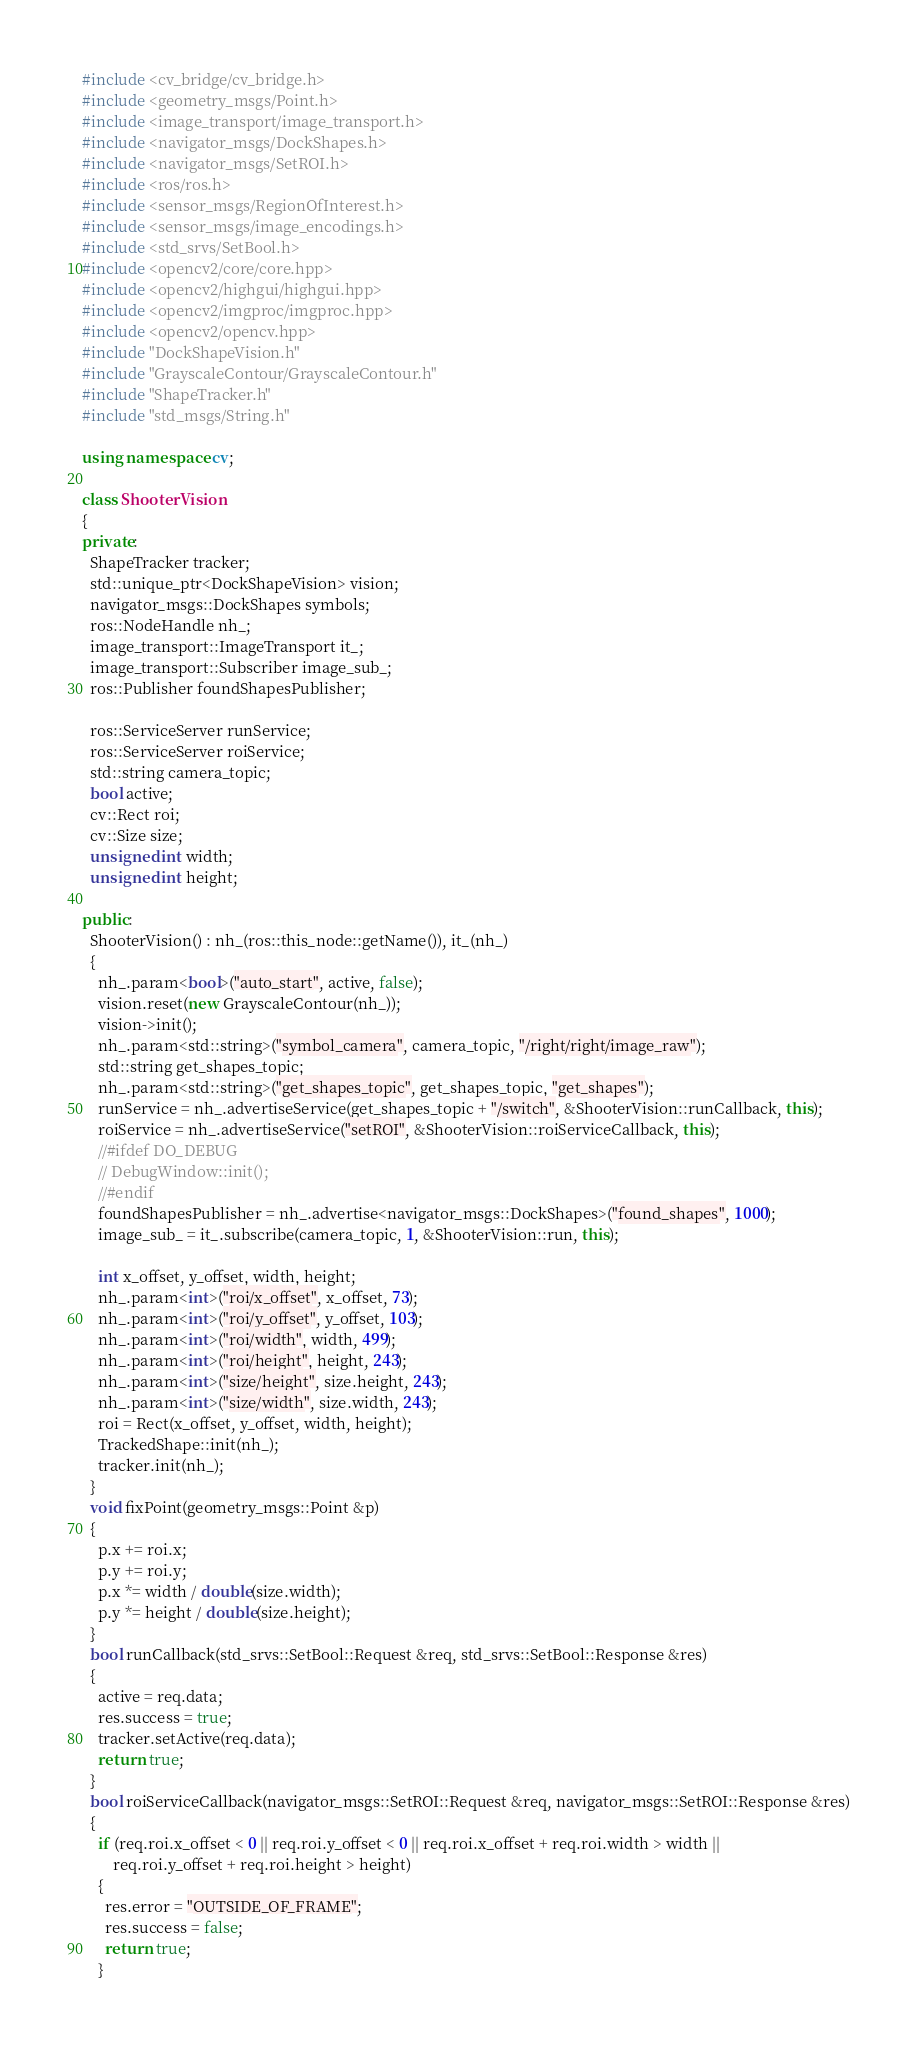Convert code to text. <code><loc_0><loc_0><loc_500><loc_500><_C++_>#include <cv_bridge/cv_bridge.h>
#include <geometry_msgs/Point.h>
#include <image_transport/image_transport.h>
#include <navigator_msgs/DockShapes.h>
#include <navigator_msgs/SetROI.h>
#include <ros/ros.h>
#include <sensor_msgs/RegionOfInterest.h>
#include <sensor_msgs/image_encodings.h>
#include <std_srvs/SetBool.h>
#include <opencv2/core/core.hpp>
#include <opencv2/highgui/highgui.hpp>
#include <opencv2/imgproc/imgproc.hpp>
#include <opencv2/opencv.hpp>
#include "DockShapeVision.h"
#include "GrayscaleContour/GrayscaleContour.h"
#include "ShapeTracker.h"
#include "std_msgs/String.h"

using namespace cv;

class ShooterVision
{
private:
  ShapeTracker tracker;
  std::unique_ptr<DockShapeVision> vision;
  navigator_msgs::DockShapes symbols;
  ros::NodeHandle nh_;
  image_transport::ImageTransport it_;
  image_transport::Subscriber image_sub_;
  ros::Publisher foundShapesPublisher;

  ros::ServiceServer runService;
  ros::ServiceServer roiService;
  std::string camera_topic;
  bool active;
  cv::Rect roi;
  cv::Size size;
  unsigned int width;
  unsigned int height;

public:
  ShooterVision() : nh_(ros::this_node::getName()), it_(nh_)
  {
    nh_.param<bool>("auto_start", active, false);
    vision.reset(new GrayscaleContour(nh_));
    vision->init();
    nh_.param<std::string>("symbol_camera", camera_topic, "/right/right/image_raw");
    std::string get_shapes_topic;
    nh_.param<std::string>("get_shapes_topic", get_shapes_topic, "get_shapes");
    runService = nh_.advertiseService(get_shapes_topic + "/switch", &ShooterVision::runCallback, this);
    roiService = nh_.advertiseService("setROI", &ShooterVision::roiServiceCallback, this);
    //#ifdef DO_DEBUG
    // DebugWindow::init();
    //#endif
    foundShapesPublisher = nh_.advertise<navigator_msgs::DockShapes>("found_shapes", 1000);
    image_sub_ = it_.subscribe(camera_topic, 1, &ShooterVision::run, this);

    int x_offset, y_offset, width, height;
    nh_.param<int>("roi/x_offset", x_offset, 73);
    nh_.param<int>("roi/y_offset", y_offset, 103);
    nh_.param<int>("roi/width", width, 499);
    nh_.param<int>("roi/height", height, 243);
    nh_.param<int>("size/height", size.height, 243);
    nh_.param<int>("size/width", size.width, 243);
    roi = Rect(x_offset, y_offset, width, height);
    TrackedShape::init(nh_);
    tracker.init(nh_);
  }
  void fixPoint(geometry_msgs::Point &p)
  {
    p.x += roi.x;
    p.y += roi.y;
    p.x *= width / double(size.width);
    p.y *= height / double(size.height);
  }
  bool runCallback(std_srvs::SetBool::Request &req, std_srvs::SetBool::Response &res)
  {
    active = req.data;
    res.success = true;
    tracker.setActive(req.data);
    return true;
  }
  bool roiServiceCallback(navigator_msgs::SetROI::Request &req, navigator_msgs::SetROI::Response &res)
  {
    if (req.roi.x_offset < 0 || req.roi.y_offset < 0 || req.roi.x_offset + req.roi.width > width ||
        req.roi.y_offset + req.roi.height > height)
    {
      res.error = "OUTSIDE_OF_FRAME";
      res.success = false;
      return true;
    }</code> 